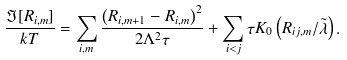<formula> <loc_0><loc_0><loc_500><loc_500>\frac { \Im [ { R _ { i , m } } ] } { k T } = \sum _ { i , m } \frac { \left ( R _ { i , m + 1 } - R _ { i , m } \right ) ^ { 2 } } { 2 \Lambda ^ { 2 } \tau } + \sum _ { i < j } \tau K _ { 0 } \left ( R _ { i j , m } / \tilde { \lambda } \right ) .</formula> 